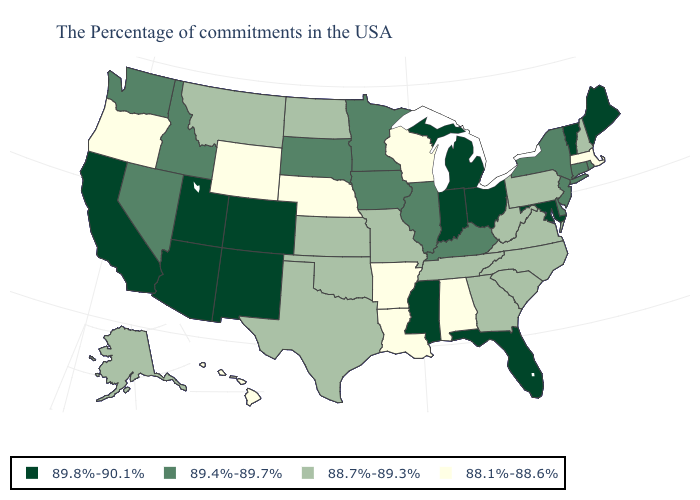Name the states that have a value in the range 88.1%-88.6%?
Concise answer only. Massachusetts, Alabama, Wisconsin, Louisiana, Arkansas, Nebraska, Wyoming, Oregon, Hawaii. What is the value of Kentucky?
Write a very short answer. 89.4%-89.7%. Among the states that border Arizona , which have the highest value?
Be succinct. Colorado, New Mexico, Utah, California. Does the first symbol in the legend represent the smallest category?
Quick response, please. No. What is the value of South Dakota?
Quick response, please. 89.4%-89.7%. Which states hav the highest value in the MidWest?
Short answer required. Ohio, Michigan, Indiana. Does the first symbol in the legend represent the smallest category?
Give a very brief answer. No. What is the lowest value in the USA?
Quick response, please. 88.1%-88.6%. What is the value of Vermont?
Write a very short answer. 89.8%-90.1%. Among the states that border Vermont , does Massachusetts have the lowest value?
Short answer required. Yes. What is the value of Mississippi?
Answer briefly. 89.8%-90.1%. Is the legend a continuous bar?
Answer briefly. No. Does North Carolina have the lowest value in the South?
Concise answer only. No. What is the value of Nebraska?
Keep it brief. 88.1%-88.6%. What is the value of Mississippi?
Be succinct. 89.8%-90.1%. 